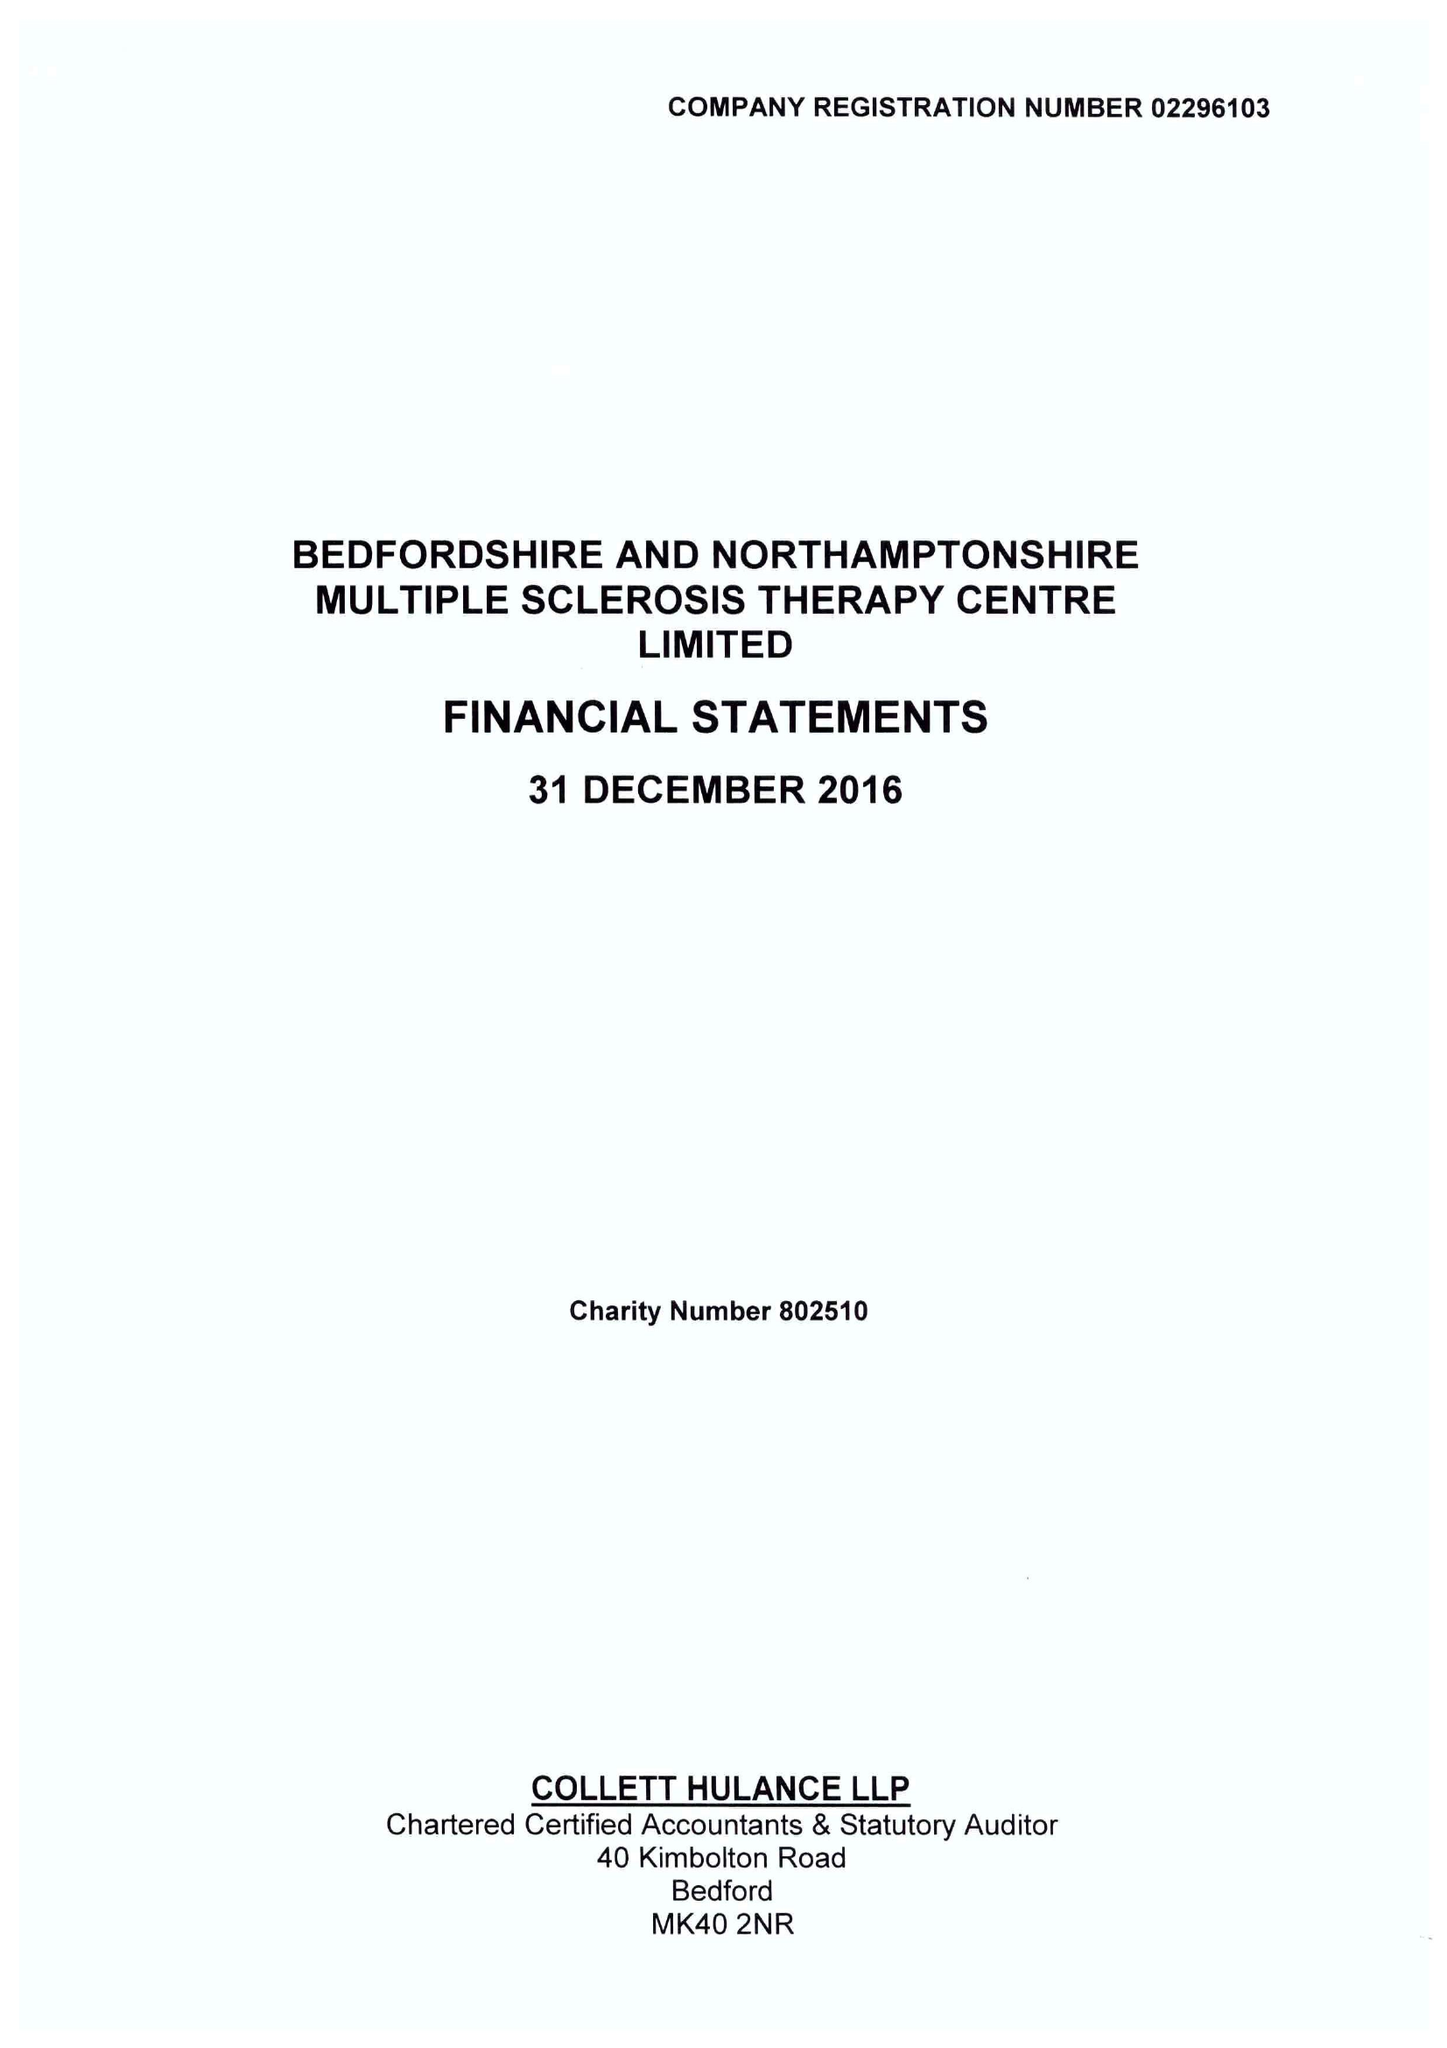What is the value for the address__post_town?
Answer the question using a single word or phrase. BEDFORD 